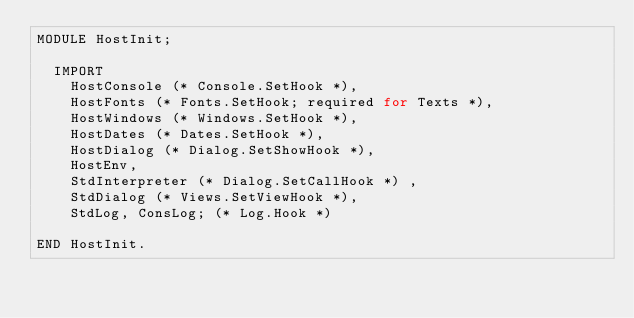Convert code to text. <code><loc_0><loc_0><loc_500><loc_500><_C++_>MODULE HostInit;

	IMPORT
		HostConsole (* Console.SetHook *),
		HostFonts (* Fonts.SetHook; required for Texts *),
		HostWindows (* Windows.SetHook *),
		HostDates (* Dates.SetHook *),
		HostDialog (* Dialog.SetShowHook *),
		HostEnv,
		StdInterpreter (* Dialog.SetCallHook *) ,
		StdDialog (* Views.SetViewHook *),
		StdLog, ConsLog; (* Log.Hook *)

END HostInit.
</code> 